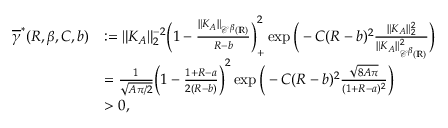Convert formula to latex. <formula><loc_0><loc_0><loc_500><loc_500>\begin{array} { r l } { \overline { \gamma } ^ { * } ( R , \beta , C , b ) } & { \colon = \| K _ { A } \| _ { 2 } ^ { - 2 } \left ( 1 - \frac { \| K _ { A } \| _ { { \ m a t h s c r C } ^ { \beta } ( { \mathbb { R } } ) } } { R - b } \right ) _ { + } ^ { 2 } \exp \left ( - C ( R - b ) ^ { 2 } \frac { \| K _ { A } \| _ { 2 } ^ { 2 } } { \| K _ { A } \| _ { { \ m a t h s c r C } ^ { \beta } ( { \mathbb { R } } ) } ^ { 2 } } \right ) } \\ & { = \frac { 1 } { \sqrt { A \pi / 2 } } \left ( 1 - \frac { 1 + R - a } { 2 ( R - b ) } \right ) ^ { 2 } \exp \left ( - C ( R - b ) ^ { 2 } \frac { \sqrt { 8 A \pi } } { ( 1 + R - a ) ^ { 2 } } \right ) } \\ & { > 0 , } \end{array}</formula> 